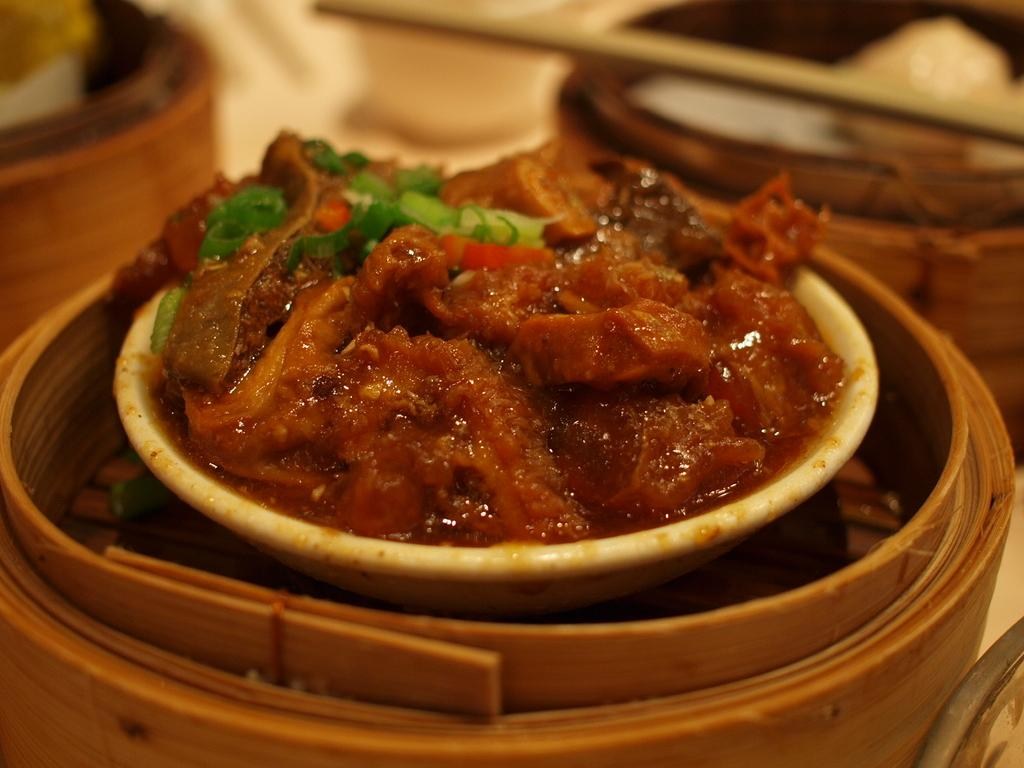What is in the bowl that is visible in the image? There is a bowl filled with food items in the image. What is the bowl placed on in the image? The bowl is placed on a wooden object. What type of watch is visible on the wooden object in the image? There is no watch present in the image; only a bowl filled with food items and a wooden object are visible. 